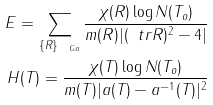<formula> <loc_0><loc_0><loc_500><loc_500>E = \sum _ { \{ R \} _ { \ G a } } \frac { \chi ( R ) \log N ( T _ { o } ) } { m ( R ) | ( \ t r R ) ^ { 2 } - 4 | } \\ H ( T ) = \frac { \chi ( T ) \log N ( T _ { o } ) } { m ( T ) | a ( T ) - a ^ { - 1 } ( T ) | ^ { 2 } }</formula> 